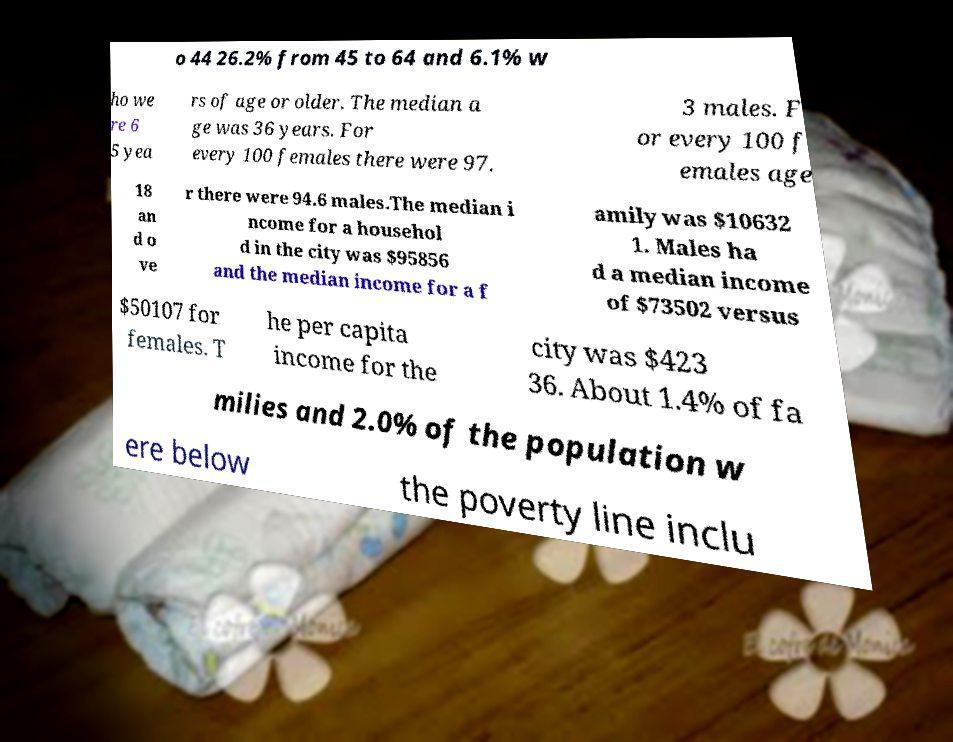Can you read and provide the text displayed in the image?This photo seems to have some interesting text. Can you extract and type it out for me? o 44 26.2% from 45 to 64 and 6.1% w ho we re 6 5 yea rs of age or older. The median a ge was 36 years. For every 100 females there were 97. 3 males. F or every 100 f emales age 18 an d o ve r there were 94.6 males.The median i ncome for a househol d in the city was $95856 and the median income for a f amily was $10632 1. Males ha d a median income of $73502 versus $50107 for females. T he per capita income for the city was $423 36. About 1.4% of fa milies and 2.0% of the population w ere below the poverty line inclu 